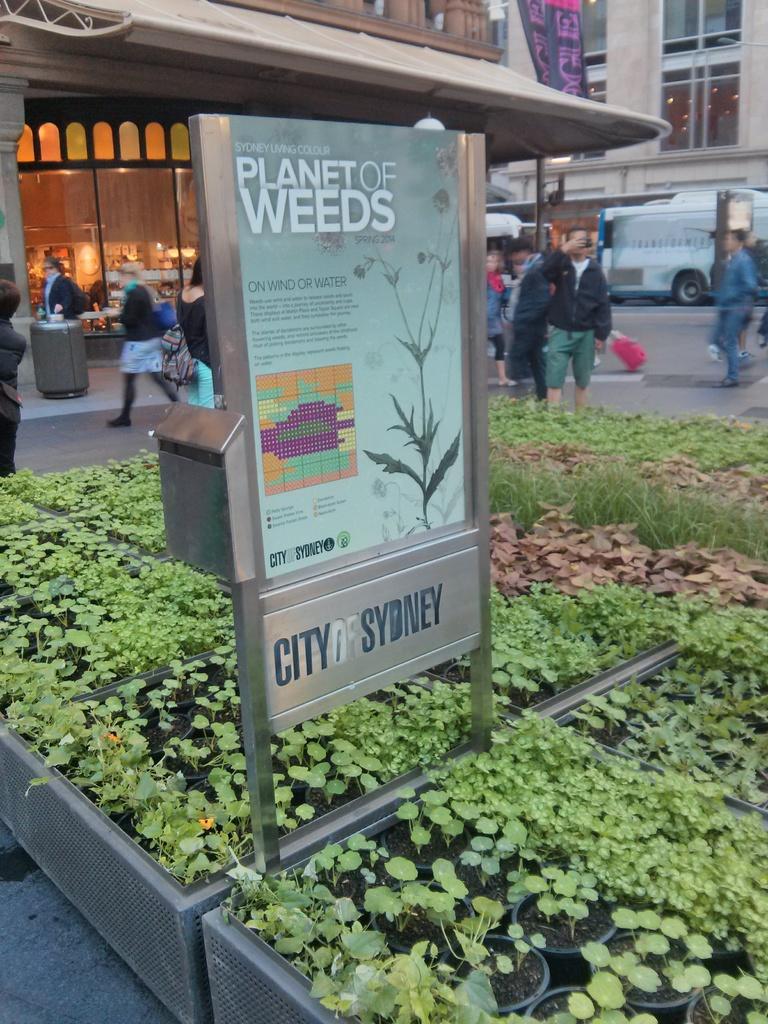Describe this image in one or two sentences. At the bottom of the image there are pots with plants and in the middle of them there is a stand with poster and box. Behind them there are few people on the road. In the background there are buildings with walls, windows, pillars, flags and glass doors. There are vehicles on the road. 